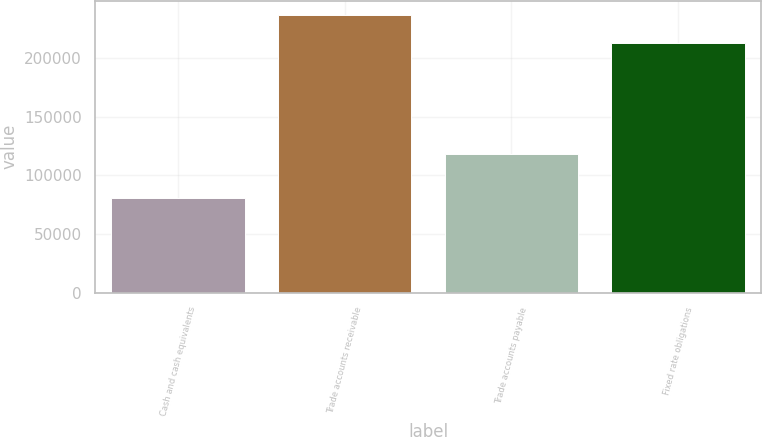<chart> <loc_0><loc_0><loc_500><loc_500><bar_chart><fcel>Cash and cash equivalents<fcel>Trade accounts receivable<fcel>Trade accounts payable<fcel>Fixed rate obligations<nl><fcel>80628<fcel>237156<fcel>117931<fcel>213397<nl></chart> 